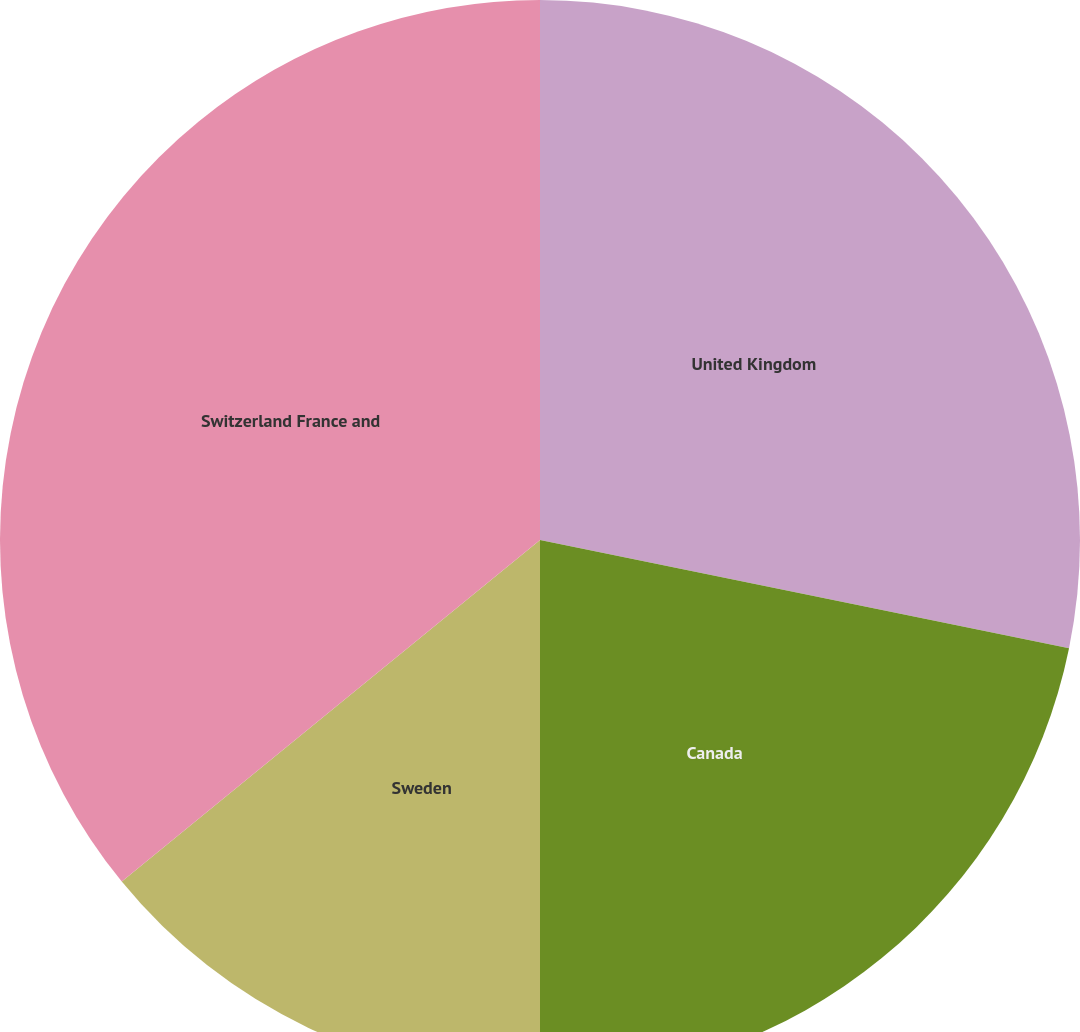<chart> <loc_0><loc_0><loc_500><loc_500><pie_chart><fcel>United Kingdom<fcel>Canada<fcel>Sweden<fcel>Switzerland France and<nl><fcel>28.21%<fcel>21.79%<fcel>14.1%<fcel>35.9%<nl></chart> 